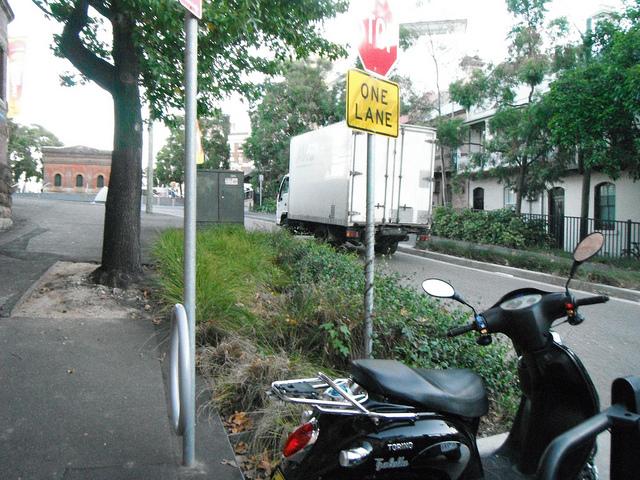Do you think the grass in the scene needs to be mowed?
Give a very brief answer. Yes. What does the yellow sign say?
Give a very brief answer. One lane. Is the street only one lane?
Keep it brief. Yes. 